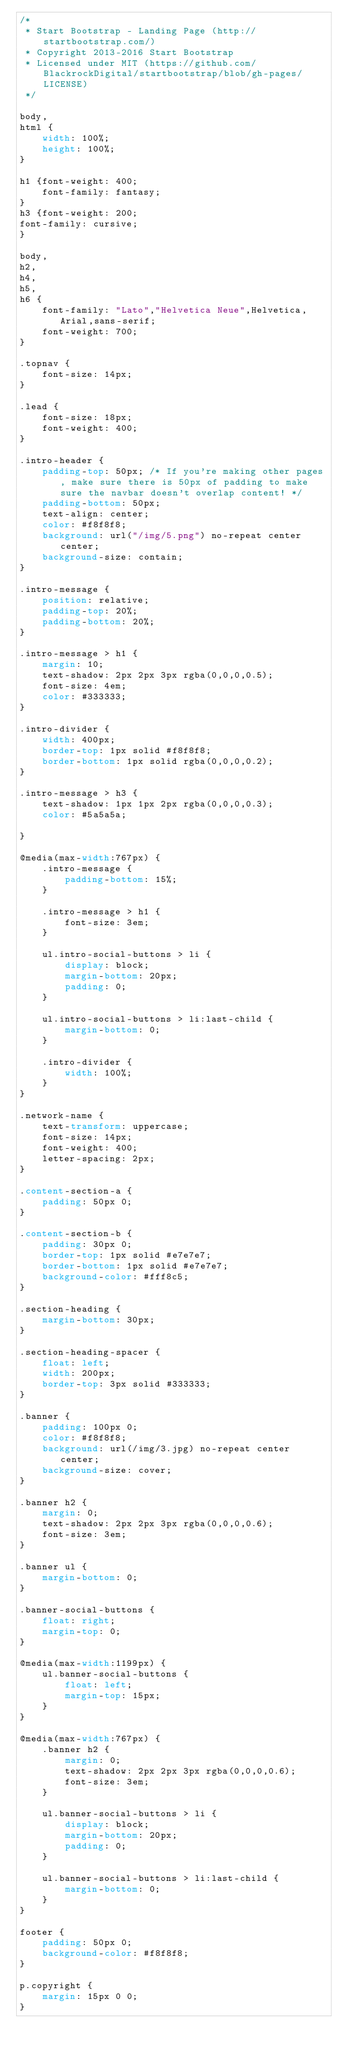Convert code to text. <code><loc_0><loc_0><loc_500><loc_500><_CSS_>/*
 * Start Bootstrap - Landing Page (http://startbootstrap.com/)
 * Copyright 2013-2016 Start Bootstrap
 * Licensed under MIT (https://github.com/BlackrockDigital/startbootstrap/blob/gh-pages/LICENSE)
 */

body,
html {
    width: 100%;
    height: 100%;
}

h1 {font-weight: 400;
    font-family: fantasy;
}
h3 {font-weight: 200;
font-family: cursive;
}

body,
h2,
h4,
h5,
h6 {
    font-family: "Lato","Helvetica Neue",Helvetica,Arial,sans-serif;
    font-weight: 700;
}

.topnav {
    font-size: 14px;
}

.lead {
    font-size: 18px;
    font-weight: 400;
}

.intro-header {
    padding-top: 50px; /* If you're making other pages, make sure there is 50px of padding to make sure the navbar doesn't overlap content! */
    padding-bottom: 50px;
    text-align: center;
    color: #f8f8f8;
    background: url("/img/5.png") no-repeat center center;
    background-size: contain;
}

.intro-message {
    position: relative;
    padding-top: 20%;
    padding-bottom: 20%;
}

.intro-message > h1 {
    margin: 10;
    text-shadow: 2px 2px 3px rgba(0,0,0,0.5);
    font-size: 4em;
    color: #333333;
}

.intro-divider {
    width: 400px;
    border-top: 1px solid #f8f8f8;
    border-bottom: 1px solid rgba(0,0,0,0.2);
}

.intro-message > h3 {
    text-shadow: 1px 1px 2px rgba(0,0,0,0.3);
    color: #5a5a5a;
    
}

@media(max-width:767px) {
    .intro-message {
        padding-bottom: 15%;
    }

    .intro-message > h1 {
        font-size: 3em;
    }

    ul.intro-social-buttons > li {
        display: block;
        margin-bottom: 20px;
        padding: 0;
    }

    ul.intro-social-buttons > li:last-child {
        margin-bottom: 0;
    }

    .intro-divider {
        width: 100%;
    }
}

.network-name {
    text-transform: uppercase;
    font-size: 14px;
    font-weight: 400;
    letter-spacing: 2px;
}

.content-section-a {
    padding: 50px 0;
}

.content-section-b {
    padding: 30px 0;
    border-top: 1px solid #e7e7e7;
    border-bottom: 1px solid #e7e7e7;
    background-color: #fff8c5;
}

.section-heading {
    margin-bottom: 30px;
}

.section-heading-spacer {
    float: left;
    width: 200px;
    border-top: 3px solid #333333;
}

.banner {
    padding: 100px 0;
    color: #f8f8f8;
    background: url(/img/3.jpg) no-repeat center center;
    background-size: cover;
}

.banner h2 {
    margin: 0;
    text-shadow: 2px 2px 3px rgba(0,0,0,0.6);
    font-size: 3em;
}

.banner ul {
    margin-bottom: 0;
}

.banner-social-buttons {
    float: right;
    margin-top: 0;
}

@media(max-width:1199px) {
    ul.banner-social-buttons {
        float: left;
        margin-top: 15px;
    }
}

@media(max-width:767px) {
    .banner h2 {
        margin: 0;
        text-shadow: 2px 2px 3px rgba(0,0,0,0.6);
        font-size: 3em;
    }

    ul.banner-social-buttons > li {
        display: block;
        margin-bottom: 20px;
        padding: 0;
    }

    ul.banner-social-buttons > li:last-child {
        margin-bottom: 0;
    }
}

footer {
    padding: 50px 0;
    background-color: #f8f8f8;
}

p.copyright {
    margin: 15px 0 0;
}</code> 